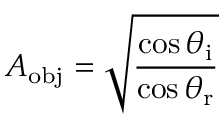Convert formula to latex. <formula><loc_0><loc_0><loc_500><loc_500>A _ { o b j } = \sqrt { \frac { \cos \theta _ { i } } { \cos \theta _ { r } } }</formula> 